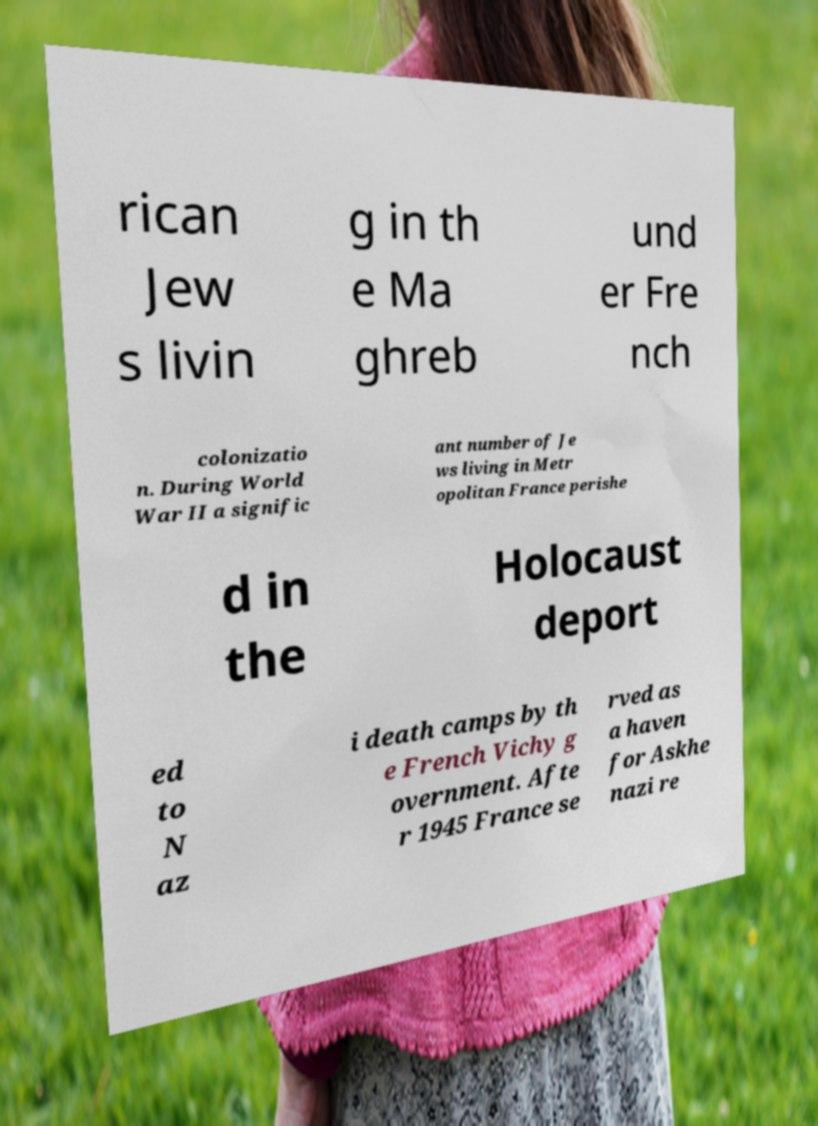Can you accurately transcribe the text from the provided image for me? rican Jew s livin g in th e Ma ghreb und er Fre nch colonizatio n. During World War II a signific ant number of Je ws living in Metr opolitan France perishe d in the Holocaust deport ed to N az i death camps by th e French Vichy g overnment. Afte r 1945 France se rved as a haven for Askhe nazi re 